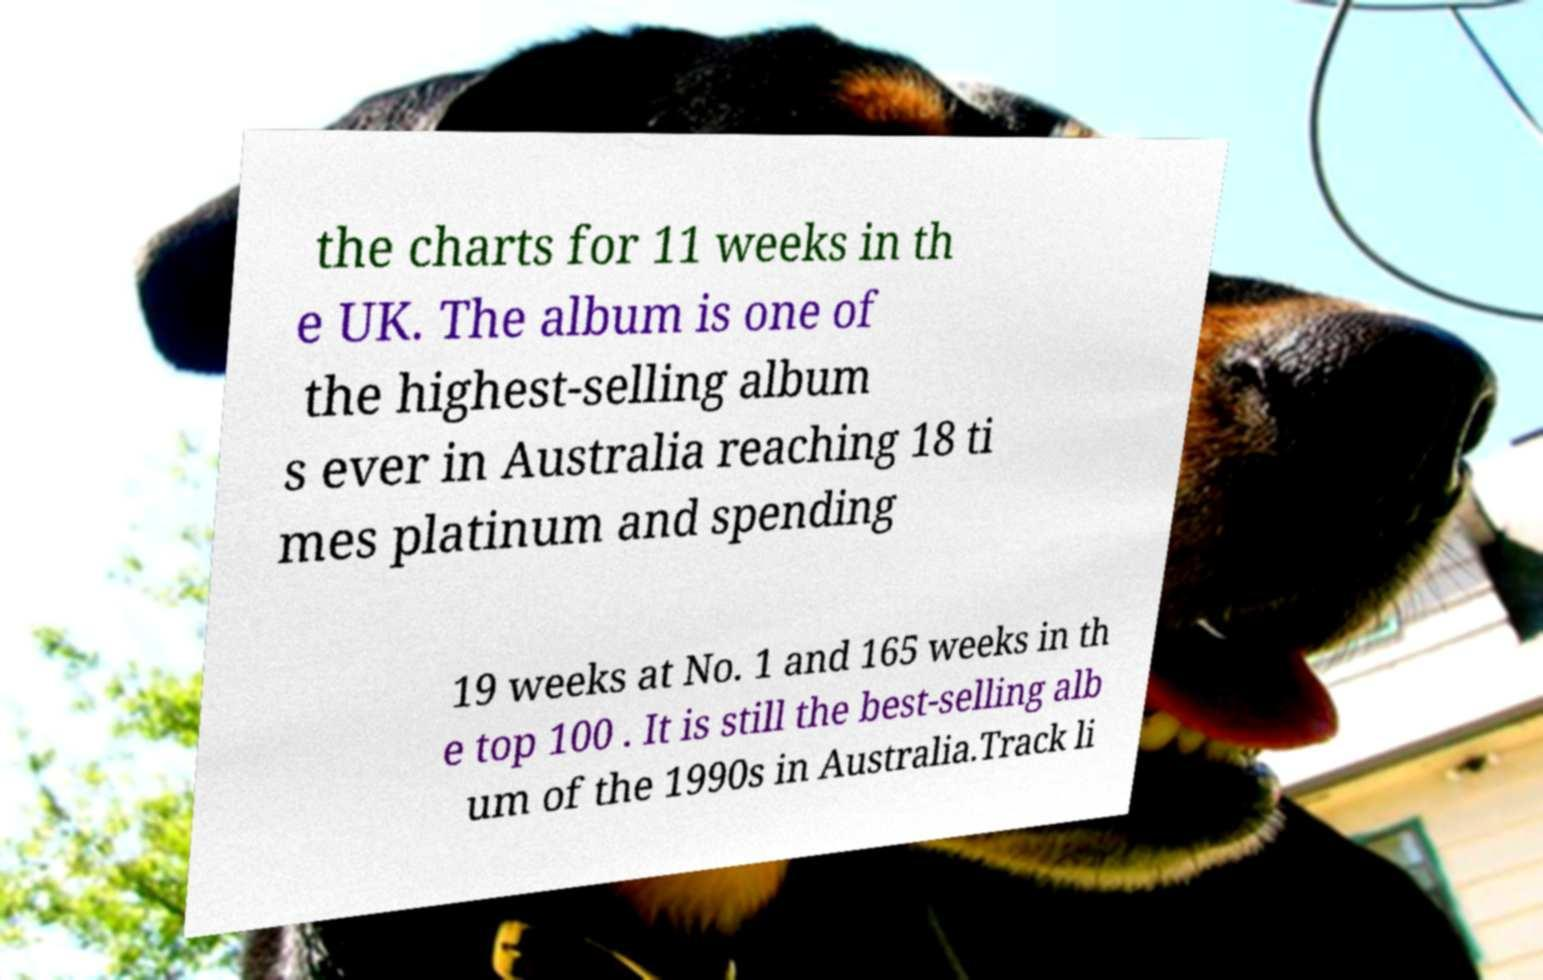Please identify and transcribe the text found in this image. the charts for 11 weeks in th e UK. The album is one of the highest-selling album s ever in Australia reaching 18 ti mes platinum and spending 19 weeks at No. 1 and 165 weeks in th e top 100 . It is still the best-selling alb um of the 1990s in Australia.Track li 